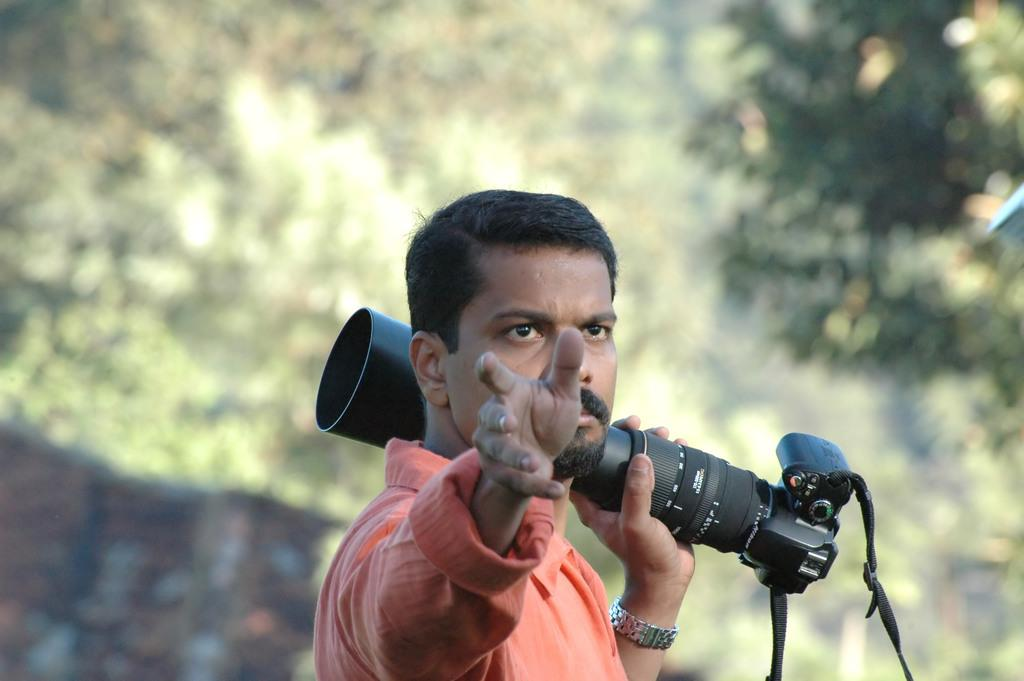Who is present in the image? There is a man in the image. What is the man holding in his left hand? The man is holding a camera in his left hand. What is the man doing in the image? The man is giving directions to someone. What type of whip is the man using to help the mint grow in the image? There is no whip or mint present in the image. The man is holding a camera and giving directions, not interacting with plants or using a whip. 